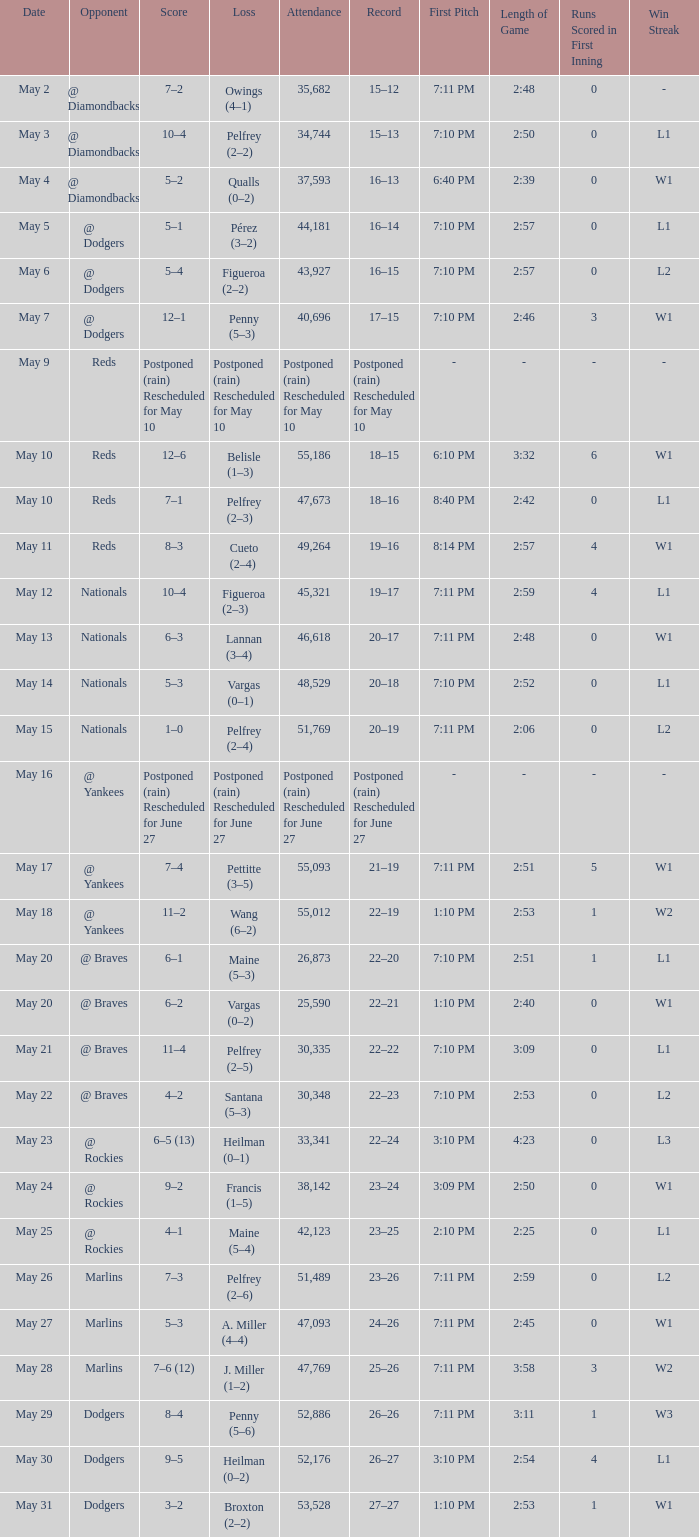Opponent of @ braves, and a Loss of pelfrey (2–5) had what score? 11–4. 